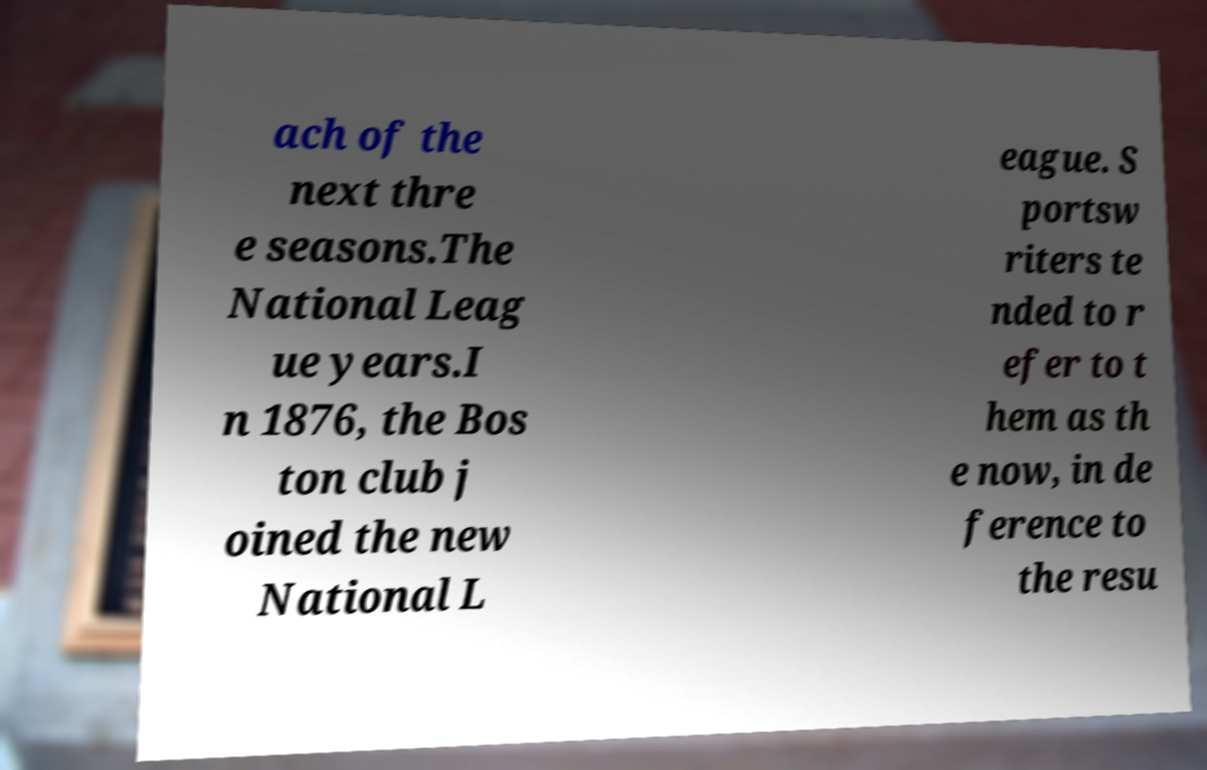What messages or text are displayed in this image? I need them in a readable, typed format. ach of the next thre e seasons.The National Leag ue years.I n 1876, the Bos ton club j oined the new National L eague. S portsw riters te nded to r efer to t hem as th e now, in de ference to the resu 